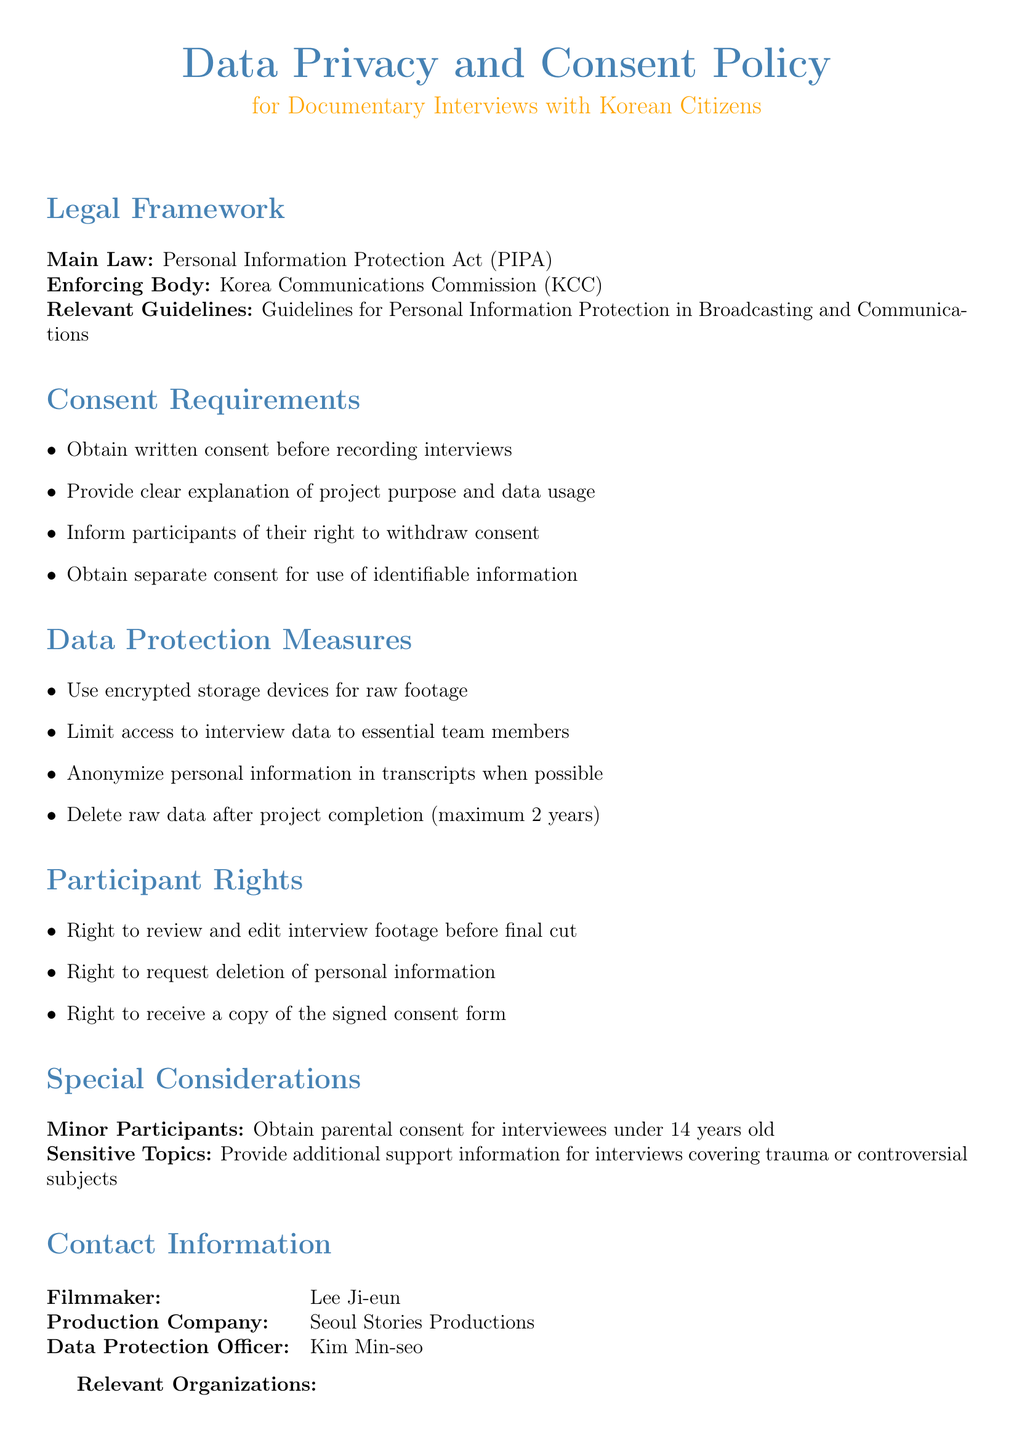What is the main law governing the document? The main law referenced in the document for data privacy is specified in the Legal Framework section.
Answer: Personal Information Protection Act (PIPA) Who enforces the main law? The enforcing body responsible for upholding the main law is listed in the Legal Framework section.
Answer: Korea Communications Commission (KCC) What should be obtained before recording interviews? The Consent Requirements section outlines what must be obtained from participants prior to interviews.
Answer: Written consent What measures are implemented for data protection? The document lists specific measures for data protection under the Data Protection Measures section.
Answer: Encrypted storage devices What right do participants have regarding their interview footage? The Participant Rights section provides information about participants' rights concerning their footage.
Answer: Right to review and edit What is the requirement for interviewing minors? The Special Considerations section specifies actions related to the consent of minors.
Answer: Obtain parental consent Which organization is mentioned as related to the film production? The Relevant Organizations section includes various related entities for film production.
Answer: Korean Film Council (KOFIC) How long can raw data be retained? The Data Protection Measures section stipulates the duration for retaining raw data after project completion.
Answer: Maximum 2 years 